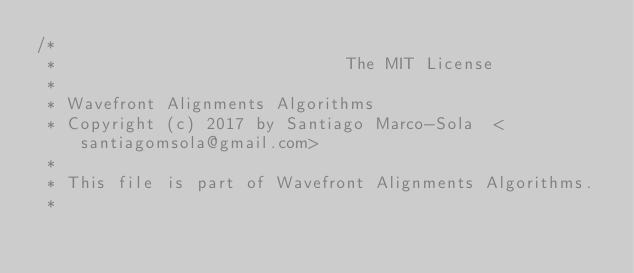Convert code to text. <code><loc_0><loc_0><loc_500><loc_500><_C++_>/*
 *                             The MIT License
 *
 * Wavefront Alignments Algorithms
 * Copyright (c) 2017 by Santiago Marco-Sola  <santiagomsola@gmail.com>
 *
 * This file is part of Wavefront Alignments Algorithms.
 *</code> 